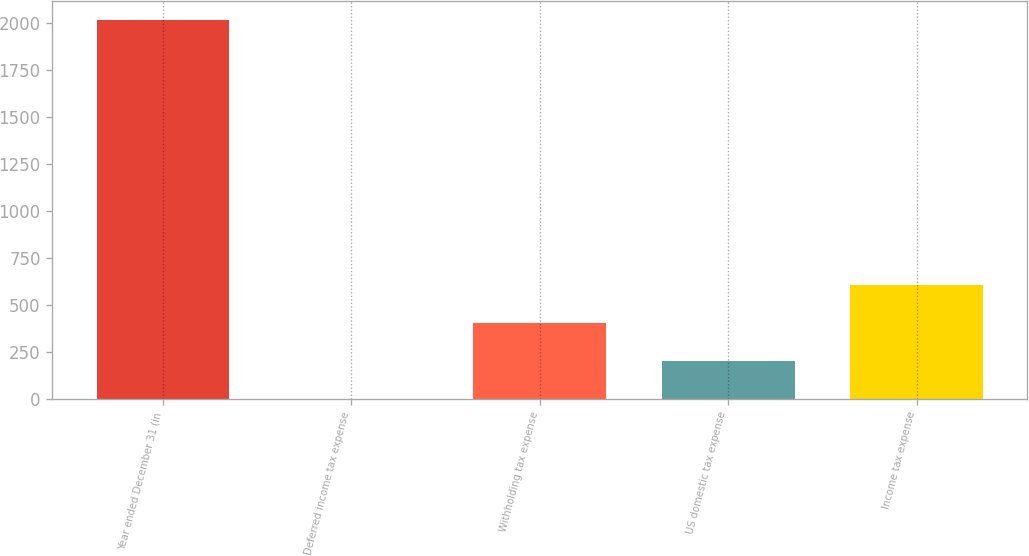Convert chart. <chart><loc_0><loc_0><loc_500><loc_500><bar_chart><fcel>Year ended December 31 (in<fcel>Deferred income tax expense<fcel>Withholding tax expense<fcel>US domestic tax expense<fcel>Income tax expense<nl><fcel>2015<fcel>2<fcel>404.6<fcel>203.3<fcel>605.9<nl></chart> 